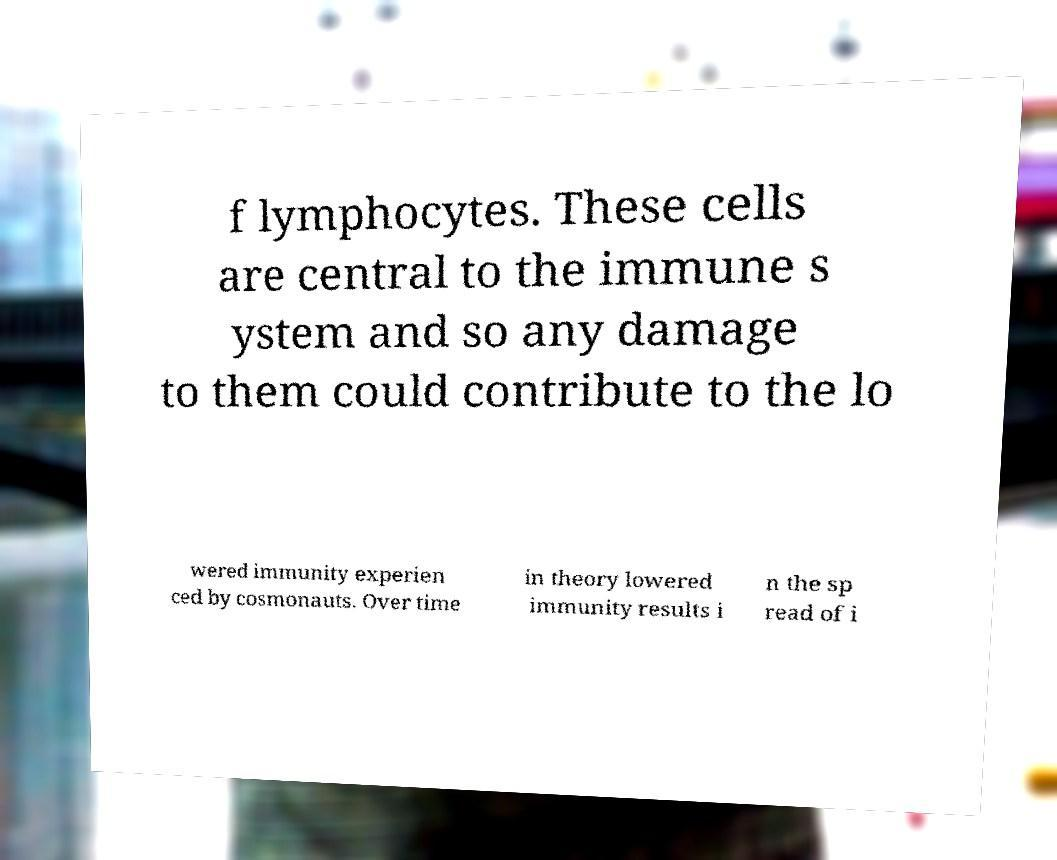What messages or text are displayed in this image? I need them in a readable, typed format. f lymphocytes. These cells are central to the immune s ystem and so any damage to them could contribute to the lo wered immunity experien ced by cosmonauts. Over time in theory lowered immunity results i n the sp read of i 